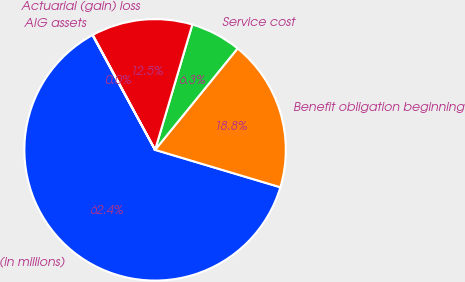Convert chart to OTSL. <chart><loc_0><loc_0><loc_500><loc_500><pie_chart><fcel>(in millions)<fcel>Benefit obligation beginning<fcel>Service cost<fcel>Actuarial (gain) loss<fcel>AIG assets<nl><fcel>62.43%<fcel>18.75%<fcel>6.27%<fcel>12.51%<fcel>0.03%<nl></chart> 